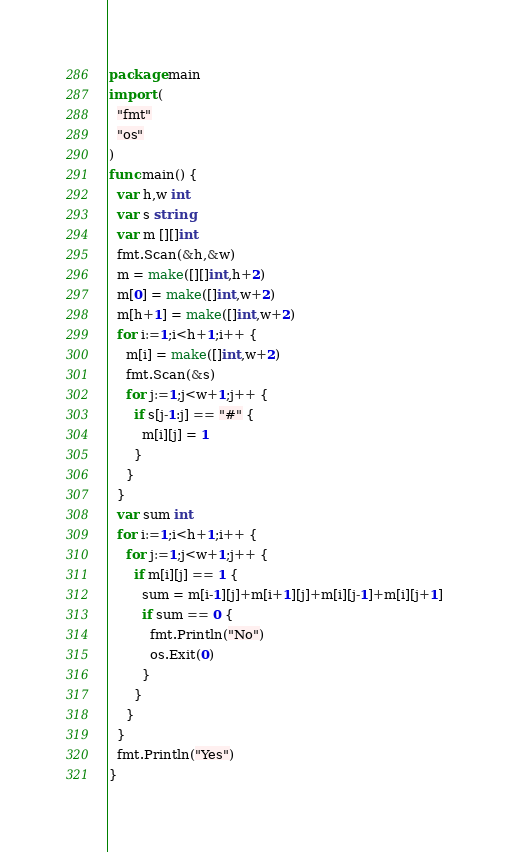Convert code to text. <code><loc_0><loc_0><loc_500><loc_500><_Go_>package main
import (
  "fmt"
  "os"
)
func main() {
  var h,w int
  var s string
  var m [][]int
  fmt.Scan(&h,&w)
  m = make([][]int,h+2)
  m[0] = make([]int,w+2)
  m[h+1] = make([]int,w+2)
  for i:=1;i<h+1;i++ {
    m[i] = make([]int,w+2)
    fmt.Scan(&s)
    for j:=1;j<w+1;j++ {
      if s[j-1:j] == "#" {
        m[i][j] = 1
      }
    }
  }
  var sum int
  for i:=1;i<h+1;i++ {
    for j:=1;j<w+1;j++ {
      if m[i][j] == 1 {
        sum = m[i-1][j]+m[i+1][j]+m[i][j-1]+m[i][j+1]
        if sum == 0 {
          fmt.Println("No")
          os.Exit(0)
        }
      }
    }
  }
  fmt.Println("Yes")
}</code> 